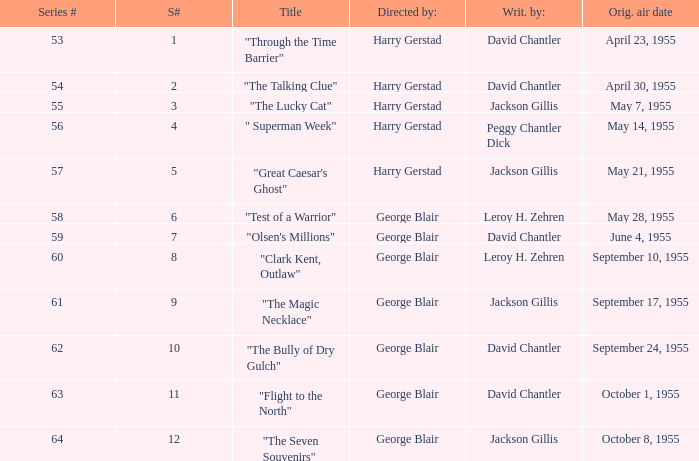Who was "The Magic Necklace" written by? Jackson Gillis. 